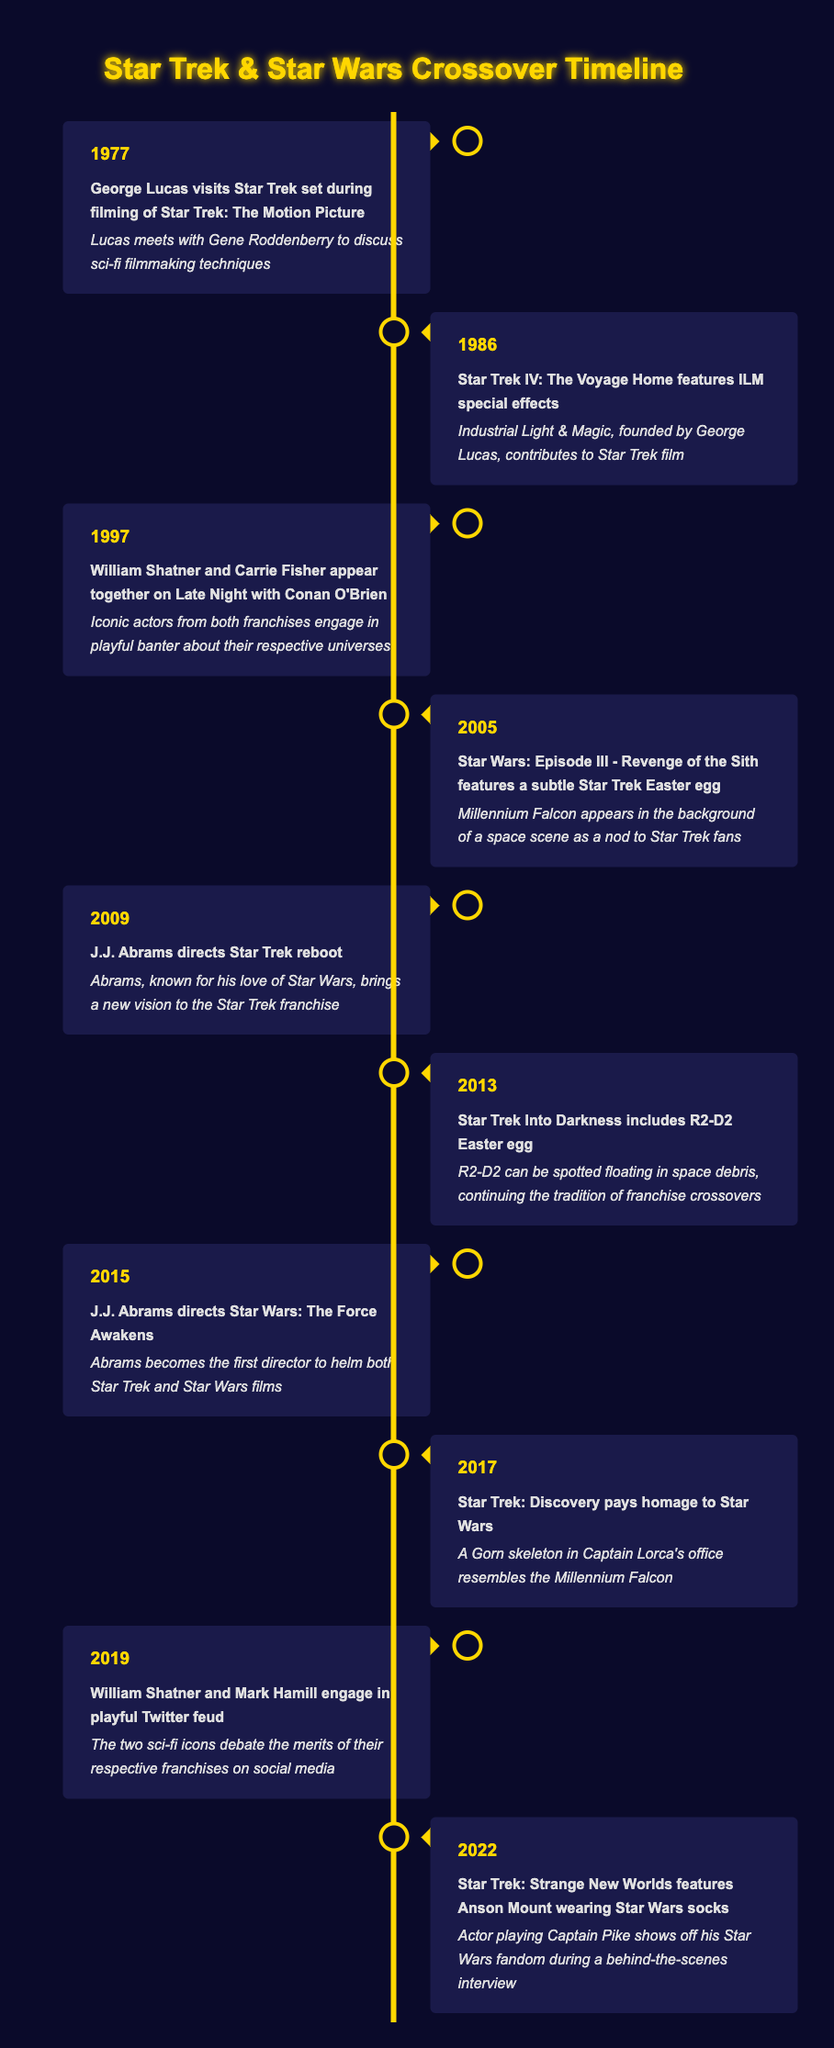What year did George Lucas visit the Star Trek set? The table lists the event "George Lucas visits Star Trek set during filming of Star Trek: The Motion Picture" occurring in the year 1977.
Answer: 1977 What significant event involving William Shatner and Carrie Fisher happened in 1997? It states that in 1997, "William Shatner and Carrie Fisher appear together on Late Night with Conan O'Brien," indicating this was an important crossover moment.
Answer: William Shatner and Carrie Fisher appear together on Late Night with Conan O'Brien How many events mentioned in the table involved J.J. Abrams? J.J. Abrams is linked to three events: in 2009 he directed the Star Trek reboot, in 2015 he directed Star Wars: The Force Awakens, and he is noted for his love of Star Wars in the context of these works. Thus, there are three distinct events associated with him.
Answer: 3 Did Star Wars: Episode III feature a Star Trek Easter egg? The description for the event in 2005 states that "Star Wars: Episode III - Revenge of the Sith features a subtle Star Trek Easter egg," confirming that this fact is indeed true.
Answer: Yes Which actor showcased their Star Wars fandom in Star Trek: Strange New Worlds? The event in 2022 mentions that "Anson Mount" was seen wearing Star Wars socks, reflecting his fandom in a behind-the-scenes interview.
Answer: Anson Mount What was common in the events of 2005 and 2013? Both events featured Easter eggs: in 2005, there was a Star Trek Easter egg in Star Wars: Episode III, and in 2013, Star Trek Into Darkness included an R2-D2 Easter egg, indicating a trend of crossover moments between the franchises.
Answer: Both events featured Easter eggs related to the other franchise What is the time gap between the event where J.J. Abrams directed the Star Trek reboot and the event where he directed Star Wars: The Force Awakens? The Star Trek reboot was in 2009 and the Star Wars film was in 2015, so the time gap is 2015 minus 2009, resulting in a gap of 6 years.
Answer: 6 years Did any events involve both actors from Star Trek and Star Wars? Yes, in 1997, William Shatner and Carrie Fisher appeared together on Late Night with Conan O'Brien, showcasing their roles in both franchises.
Answer: Yes What kind of homage did Star Trek: Discovery pay to Star Wars in 2017? It mentioned that Star Trek: Discovery included "A Gorn skeleton in Captain Lorca's office resembles the Millennium Falcon," indicating a direct visual homage to Star Wars.
Answer: A Gorn skeleton resembling the Millennium Falcon 